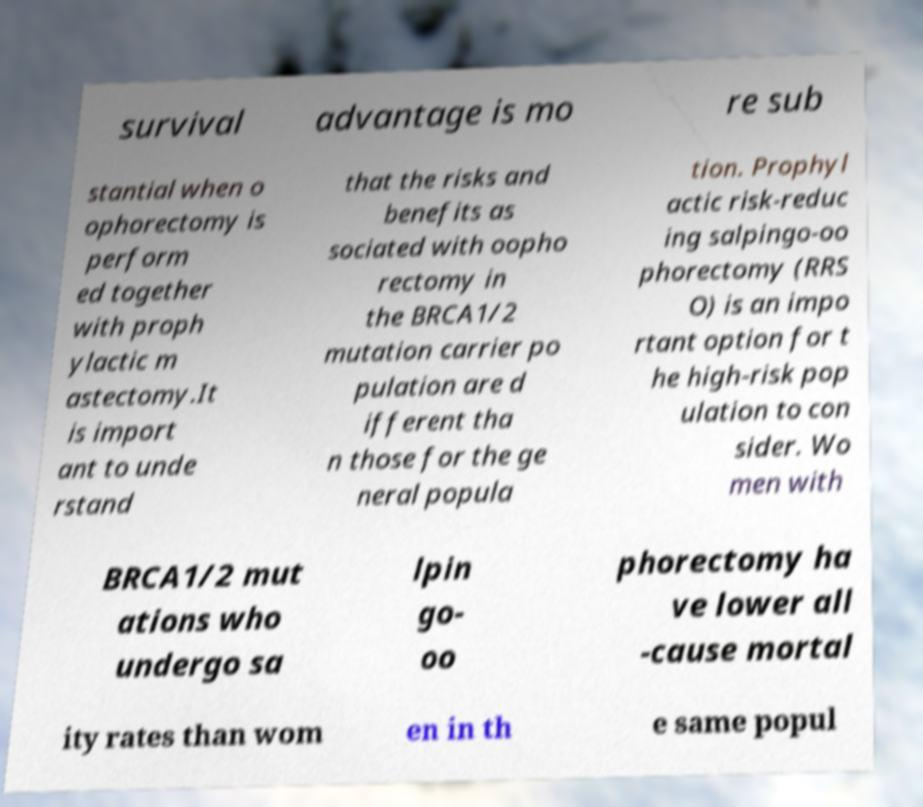Can you read and provide the text displayed in the image?This photo seems to have some interesting text. Can you extract and type it out for me? survival advantage is mo re sub stantial when o ophorectomy is perform ed together with proph ylactic m astectomy.It is import ant to unde rstand that the risks and benefits as sociated with oopho rectomy in the BRCA1/2 mutation carrier po pulation are d ifferent tha n those for the ge neral popula tion. Prophyl actic risk-reduc ing salpingo-oo phorectomy (RRS O) is an impo rtant option for t he high-risk pop ulation to con sider. Wo men with BRCA1/2 mut ations who undergo sa lpin go- oo phorectomy ha ve lower all -cause mortal ity rates than wom en in th e same popul 